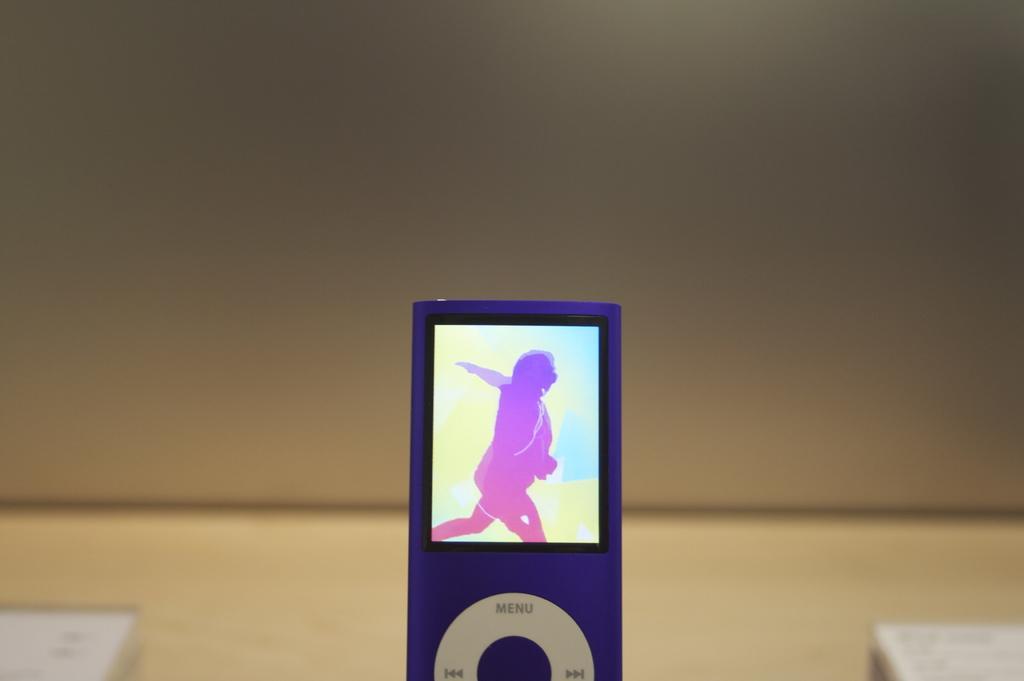Could you give a brief overview of what you see in this image? Front of the image there is an iPod. We can see screen on this iPod. Background it is blur. 